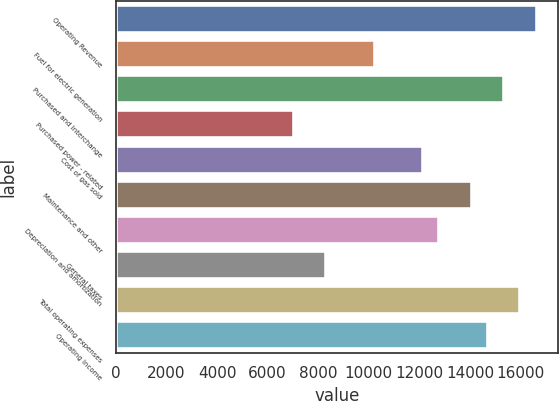Convert chart to OTSL. <chart><loc_0><loc_0><loc_500><loc_500><bar_chart><fcel>Operating Revenue<fcel>Fuel for electric generation<fcel>Purchased and interchange<fcel>Purchased power - related<fcel>Cost of gas sold<fcel>Maintenance and other<fcel>Depreciation and amortization<fcel>General taxes<fcel>Total operating expenses<fcel>Operating Income<nl><fcel>16634.2<fcel>10237.2<fcel>15354.8<fcel>7038.69<fcel>12156.3<fcel>14075.4<fcel>12796<fcel>8318.09<fcel>15994.5<fcel>14715.1<nl></chart> 